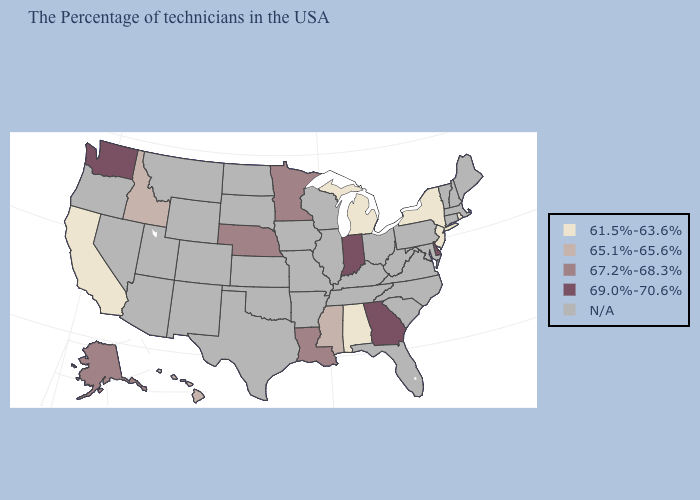What is the highest value in the South ?
Short answer required. 69.0%-70.6%. Name the states that have a value in the range N/A?
Give a very brief answer. Maine, Massachusetts, New Hampshire, Vermont, Connecticut, Maryland, Pennsylvania, Virginia, North Carolina, South Carolina, West Virginia, Ohio, Florida, Kentucky, Tennessee, Wisconsin, Illinois, Missouri, Arkansas, Iowa, Kansas, Oklahoma, Texas, South Dakota, North Dakota, Wyoming, Colorado, New Mexico, Utah, Montana, Arizona, Nevada, Oregon. What is the value of Minnesota?
Be succinct. 67.2%-68.3%. Which states have the lowest value in the South?
Give a very brief answer. Alabama. Name the states that have a value in the range N/A?
Short answer required. Maine, Massachusetts, New Hampshire, Vermont, Connecticut, Maryland, Pennsylvania, Virginia, North Carolina, South Carolina, West Virginia, Ohio, Florida, Kentucky, Tennessee, Wisconsin, Illinois, Missouri, Arkansas, Iowa, Kansas, Oklahoma, Texas, South Dakota, North Dakota, Wyoming, Colorado, New Mexico, Utah, Montana, Arizona, Nevada, Oregon. Name the states that have a value in the range N/A?
Short answer required. Maine, Massachusetts, New Hampshire, Vermont, Connecticut, Maryland, Pennsylvania, Virginia, North Carolina, South Carolina, West Virginia, Ohio, Florida, Kentucky, Tennessee, Wisconsin, Illinois, Missouri, Arkansas, Iowa, Kansas, Oklahoma, Texas, South Dakota, North Dakota, Wyoming, Colorado, New Mexico, Utah, Montana, Arizona, Nevada, Oregon. Which states have the lowest value in the USA?
Give a very brief answer. Rhode Island, New York, New Jersey, Michigan, Alabama, California. Which states have the lowest value in the West?
Short answer required. California. Name the states that have a value in the range N/A?
Quick response, please. Maine, Massachusetts, New Hampshire, Vermont, Connecticut, Maryland, Pennsylvania, Virginia, North Carolina, South Carolina, West Virginia, Ohio, Florida, Kentucky, Tennessee, Wisconsin, Illinois, Missouri, Arkansas, Iowa, Kansas, Oklahoma, Texas, South Dakota, North Dakota, Wyoming, Colorado, New Mexico, Utah, Montana, Arizona, Nevada, Oregon. What is the highest value in the USA?
Concise answer only. 69.0%-70.6%. What is the value of Utah?
Write a very short answer. N/A. What is the value of Wisconsin?
Write a very short answer. N/A. 